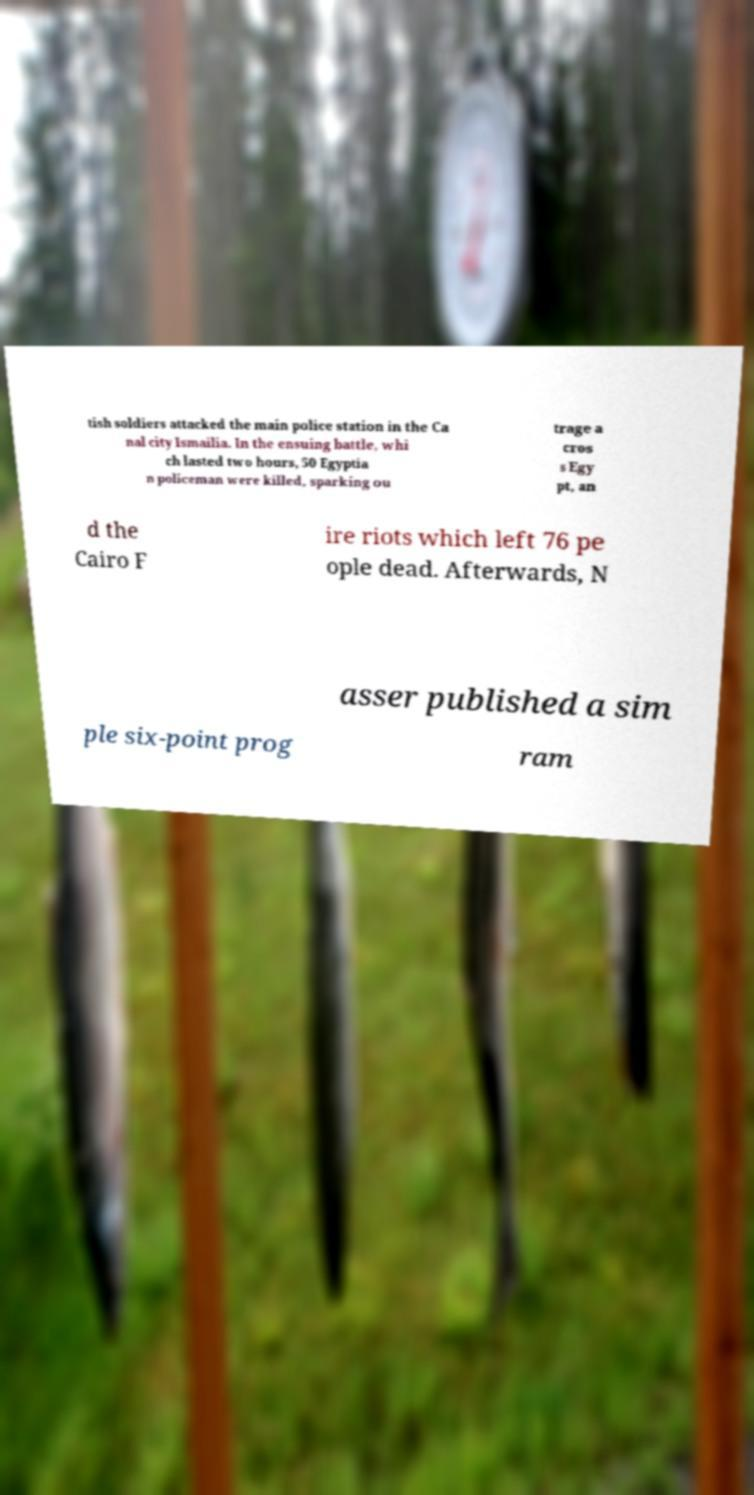What messages or text are displayed in this image? I need them in a readable, typed format. tish soldiers attacked the main police station in the Ca nal city Ismailia. In the ensuing battle, whi ch lasted two hours, 50 Egyptia n policeman were killed, sparking ou trage a cros s Egy pt, an d the Cairo F ire riots which left 76 pe ople dead. Afterwards, N asser published a sim ple six-point prog ram 